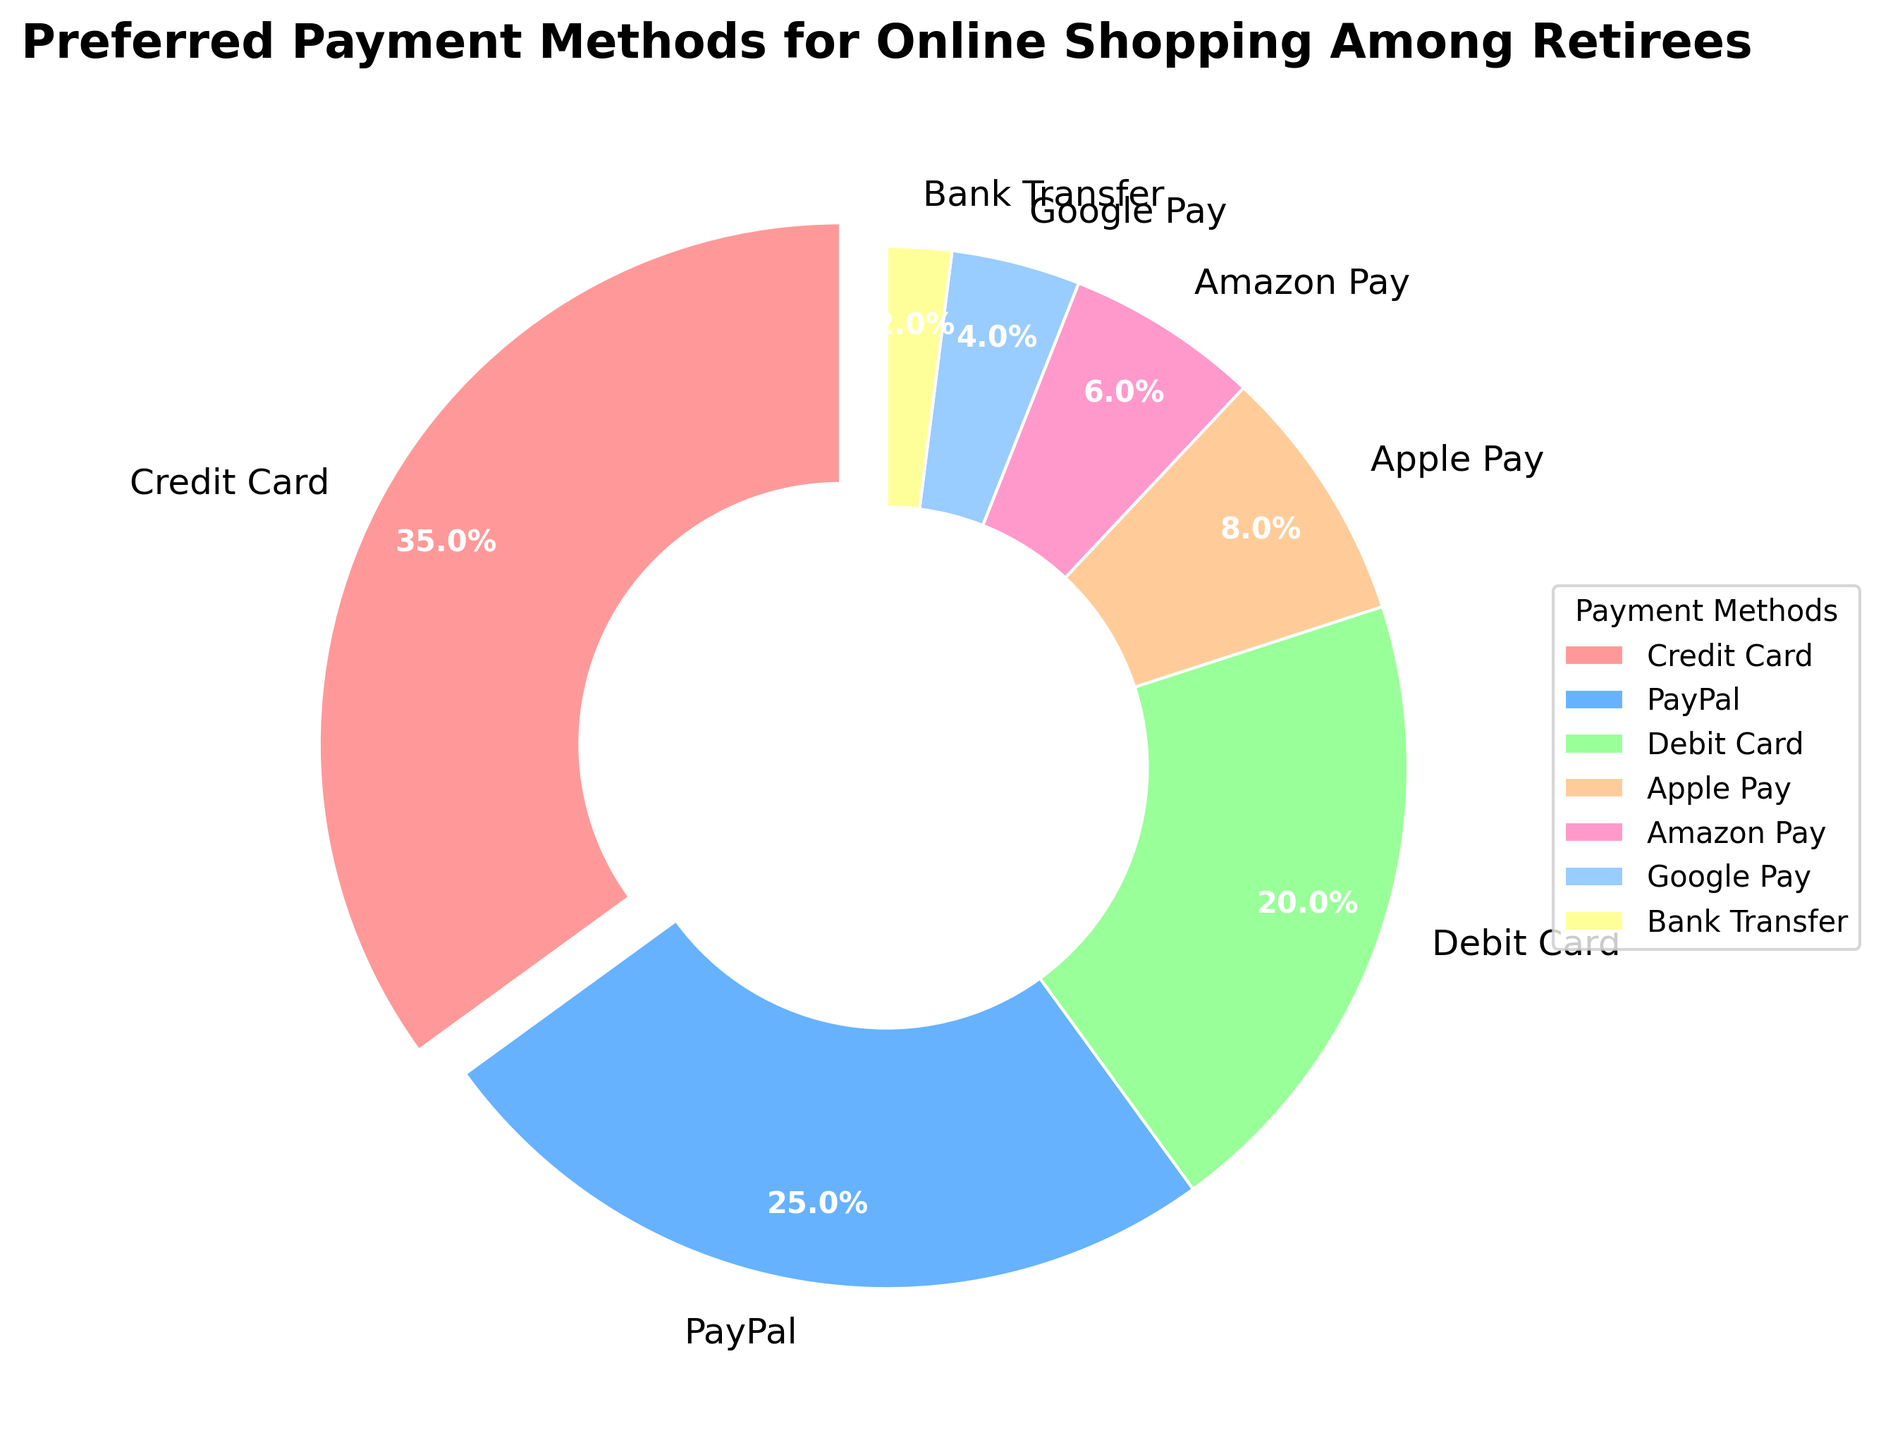Which payment method is the most preferred among retirees for online shopping? By looking at the chart, the label with the largest wedge indicates the most preferred payment method. The largest wedge corresponds to Credit Card at 35%.
Answer: Credit Card How much more popular is Credit Card compared to Google Pay? To find this, we subtract the percentage of Google Pay from the percentage of Credit Card. 35% - 4% = 31%.
Answer: 31% What is the combined percentage of retirees using Apple Pay and Amazon Pay? Add the percentages of Apple Pay and Amazon Pay. 8% + 6% = 14%.
Answer: 14% Which payment methods have a wedge with a color in the blue family? By checking the colors in the chart, PayPal (a shade of blue) and Google Pay (another shade of blue) have blue wedges.
Answer: PayPal and Google Pay What is the smallest payment method by percentage shown in the chart? By checking the chart, the smallest wedge represents Bank Transfer with 2%.
Answer: Bank Transfer Which two payment methods together make up 45% of the preference? Adding various combinations from the chart, we find that Credit Card (35%) and PayPal (25%) together make 60%, which is too high. Try Debit Card (20%) and PayPal (25%), which sum to 45%.
Answer: Debit Card and PayPal Is PayPal more or less popular than Debit Card for online shopping among retirees? By how much? Compare the percentages of PayPal and Debit Card. PayPal is 25% and Debit Card is 20%. PayPal is (25% - 20% = 5%) more popular.
Answer: More by 5% What percentage of retirees uses payment methods other than Credit Card? Subtract the percentage of Credit Card from 100%. 100% - 35% = 65%.
Answer: 65% Are there more retirees using PayPal or those using Debit Card and Apple Pay combined? Add the percentages of Debit Card and Apple Pay (20% + 8% = 28%) and compare it to PayPal (25%). Debit Card and Apple Pay combined (28%) is more than PayPal (25%).
Answer: Debit Card and Apple Pay combined What fraction of the diagram's total percentage is occupied by Amazon Pay and Google Pay together? Add the percentages of Amazon Pay and Google Pay and divide by the total percentage (100%). (6% + 4%) / 100% = 10 / 100 = 1/10.
Answer: 1/10 